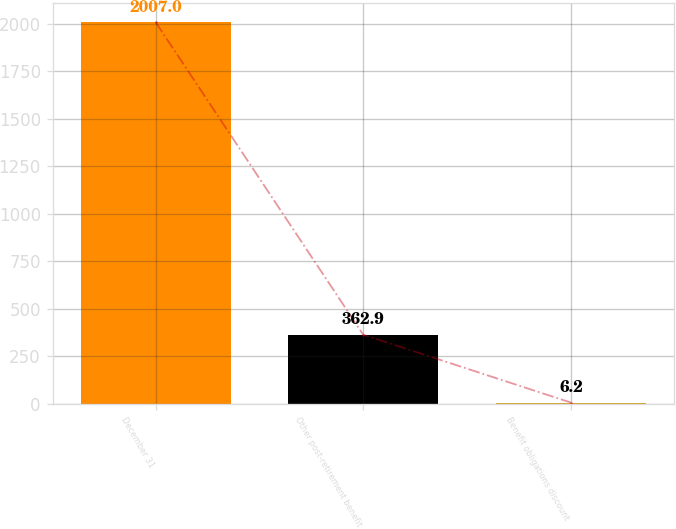<chart> <loc_0><loc_0><loc_500><loc_500><bar_chart><fcel>December 31<fcel>Other post-retirement benefit<fcel>Benefit obligations discount<nl><fcel>2007<fcel>362.9<fcel>6.2<nl></chart> 